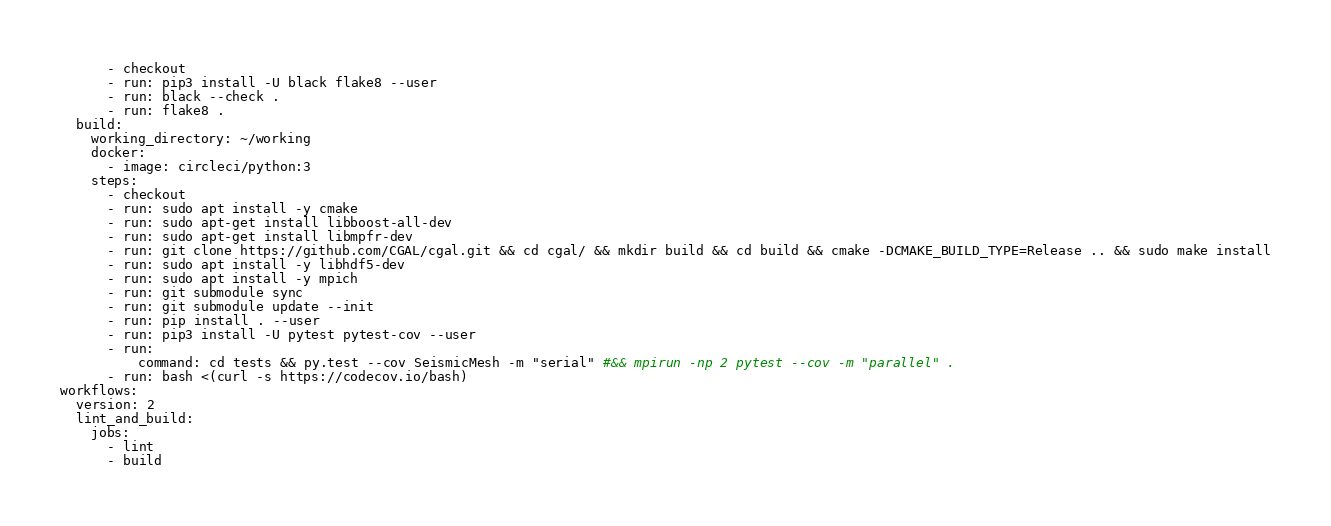<code> <loc_0><loc_0><loc_500><loc_500><_YAML_>      - checkout
      - run: pip3 install -U black flake8 --user
      - run: black --check .
      - run: flake8 .
  build:
    working_directory: ~/working
    docker:
      - image: circleci/python:3
    steps:
      - checkout
      - run: sudo apt install -y cmake
      - run: sudo apt-get install libboost-all-dev
      - run: sudo apt-get install libmpfr-dev
      - run: git clone https://github.com/CGAL/cgal.git && cd cgal/ && mkdir build && cd build && cmake -DCMAKE_BUILD_TYPE=Release .. && sudo make install
      - run: sudo apt install -y libhdf5-dev
      - run: sudo apt install -y mpich
      - run: git submodule sync
      - run: git submodule update --init
      - run: pip install . --user
      - run: pip3 install -U pytest pytest-cov --user
      - run:
          command: cd tests && py.test --cov SeismicMesh -m "serial" #&& mpirun -np 2 pytest --cov -m "parallel" .
      - run: bash <(curl -s https://codecov.io/bash)
workflows:
  version: 2
  lint_and_build:
    jobs:
      - lint
      - build
</code> 